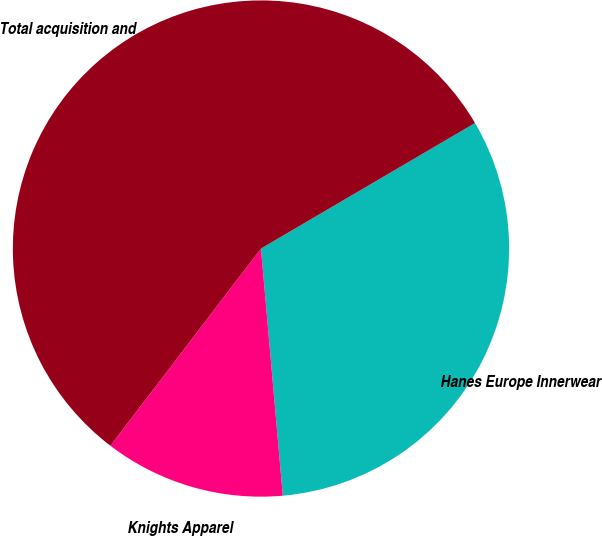<chart> <loc_0><loc_0><loc_500><loc_500><pie_chart><fcel>Hanes Europe Innerwear<fcel>Knights Apparel<fcel>Total acquisition and<nl><fcel>32.04%<fcel>11.78%<fcel>56.18%<nl></chart> 